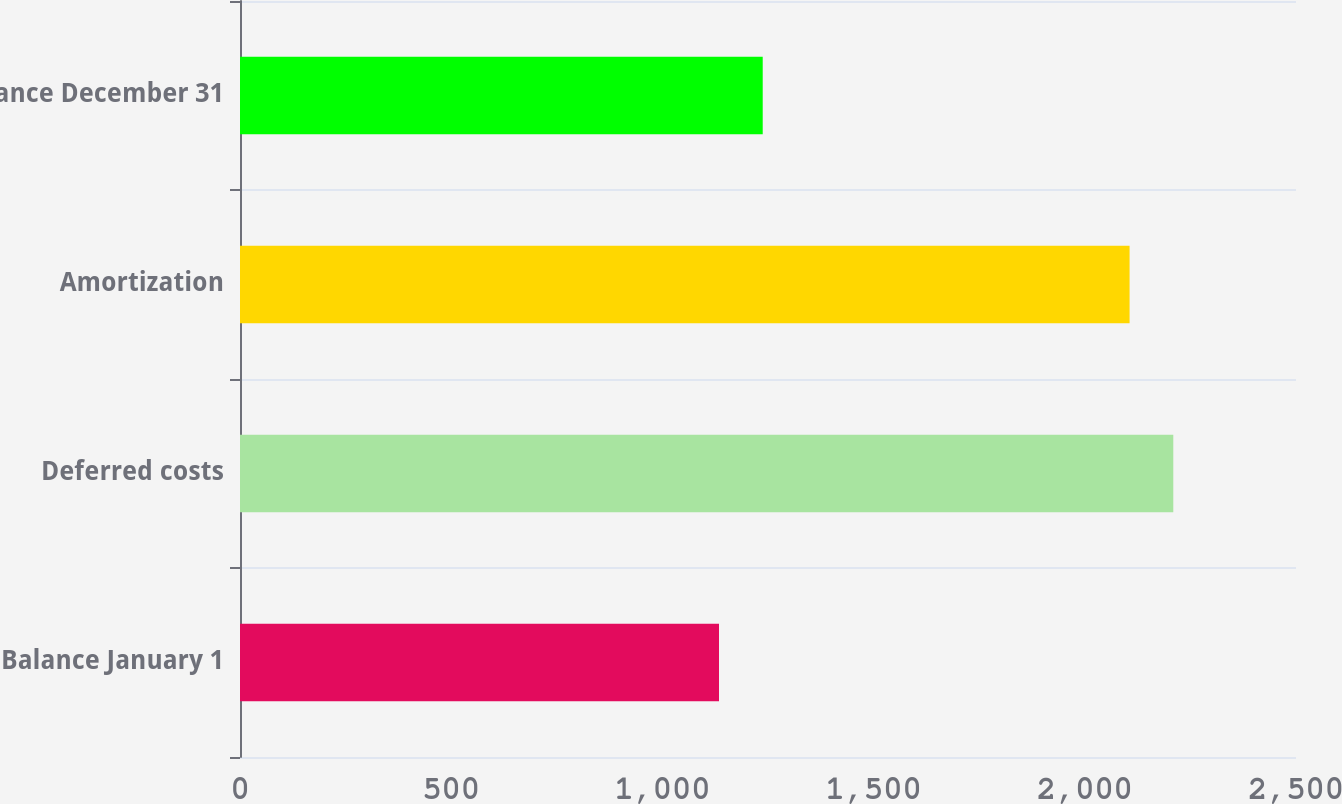Convert chart to OTSL. <chart><loc_0><loc_0><loc_500><loc_500><bar_chart><fcel>Balance January 1<fcel>Deferred costs<fcel>Amortization<fcel>Balance December 31<nl><fcel>1134<fcel>2209.5<fcel>2106<fcel>1237.5<nl></chart> 